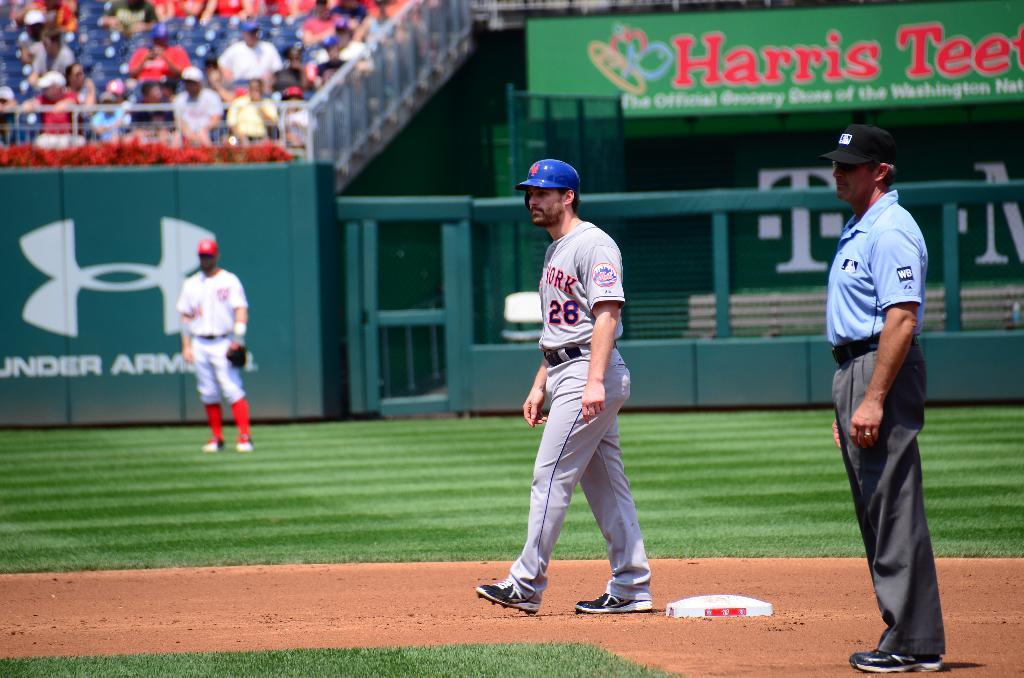<image>
Summarize the visual content of the image. a player at second base with a New York jersey on 